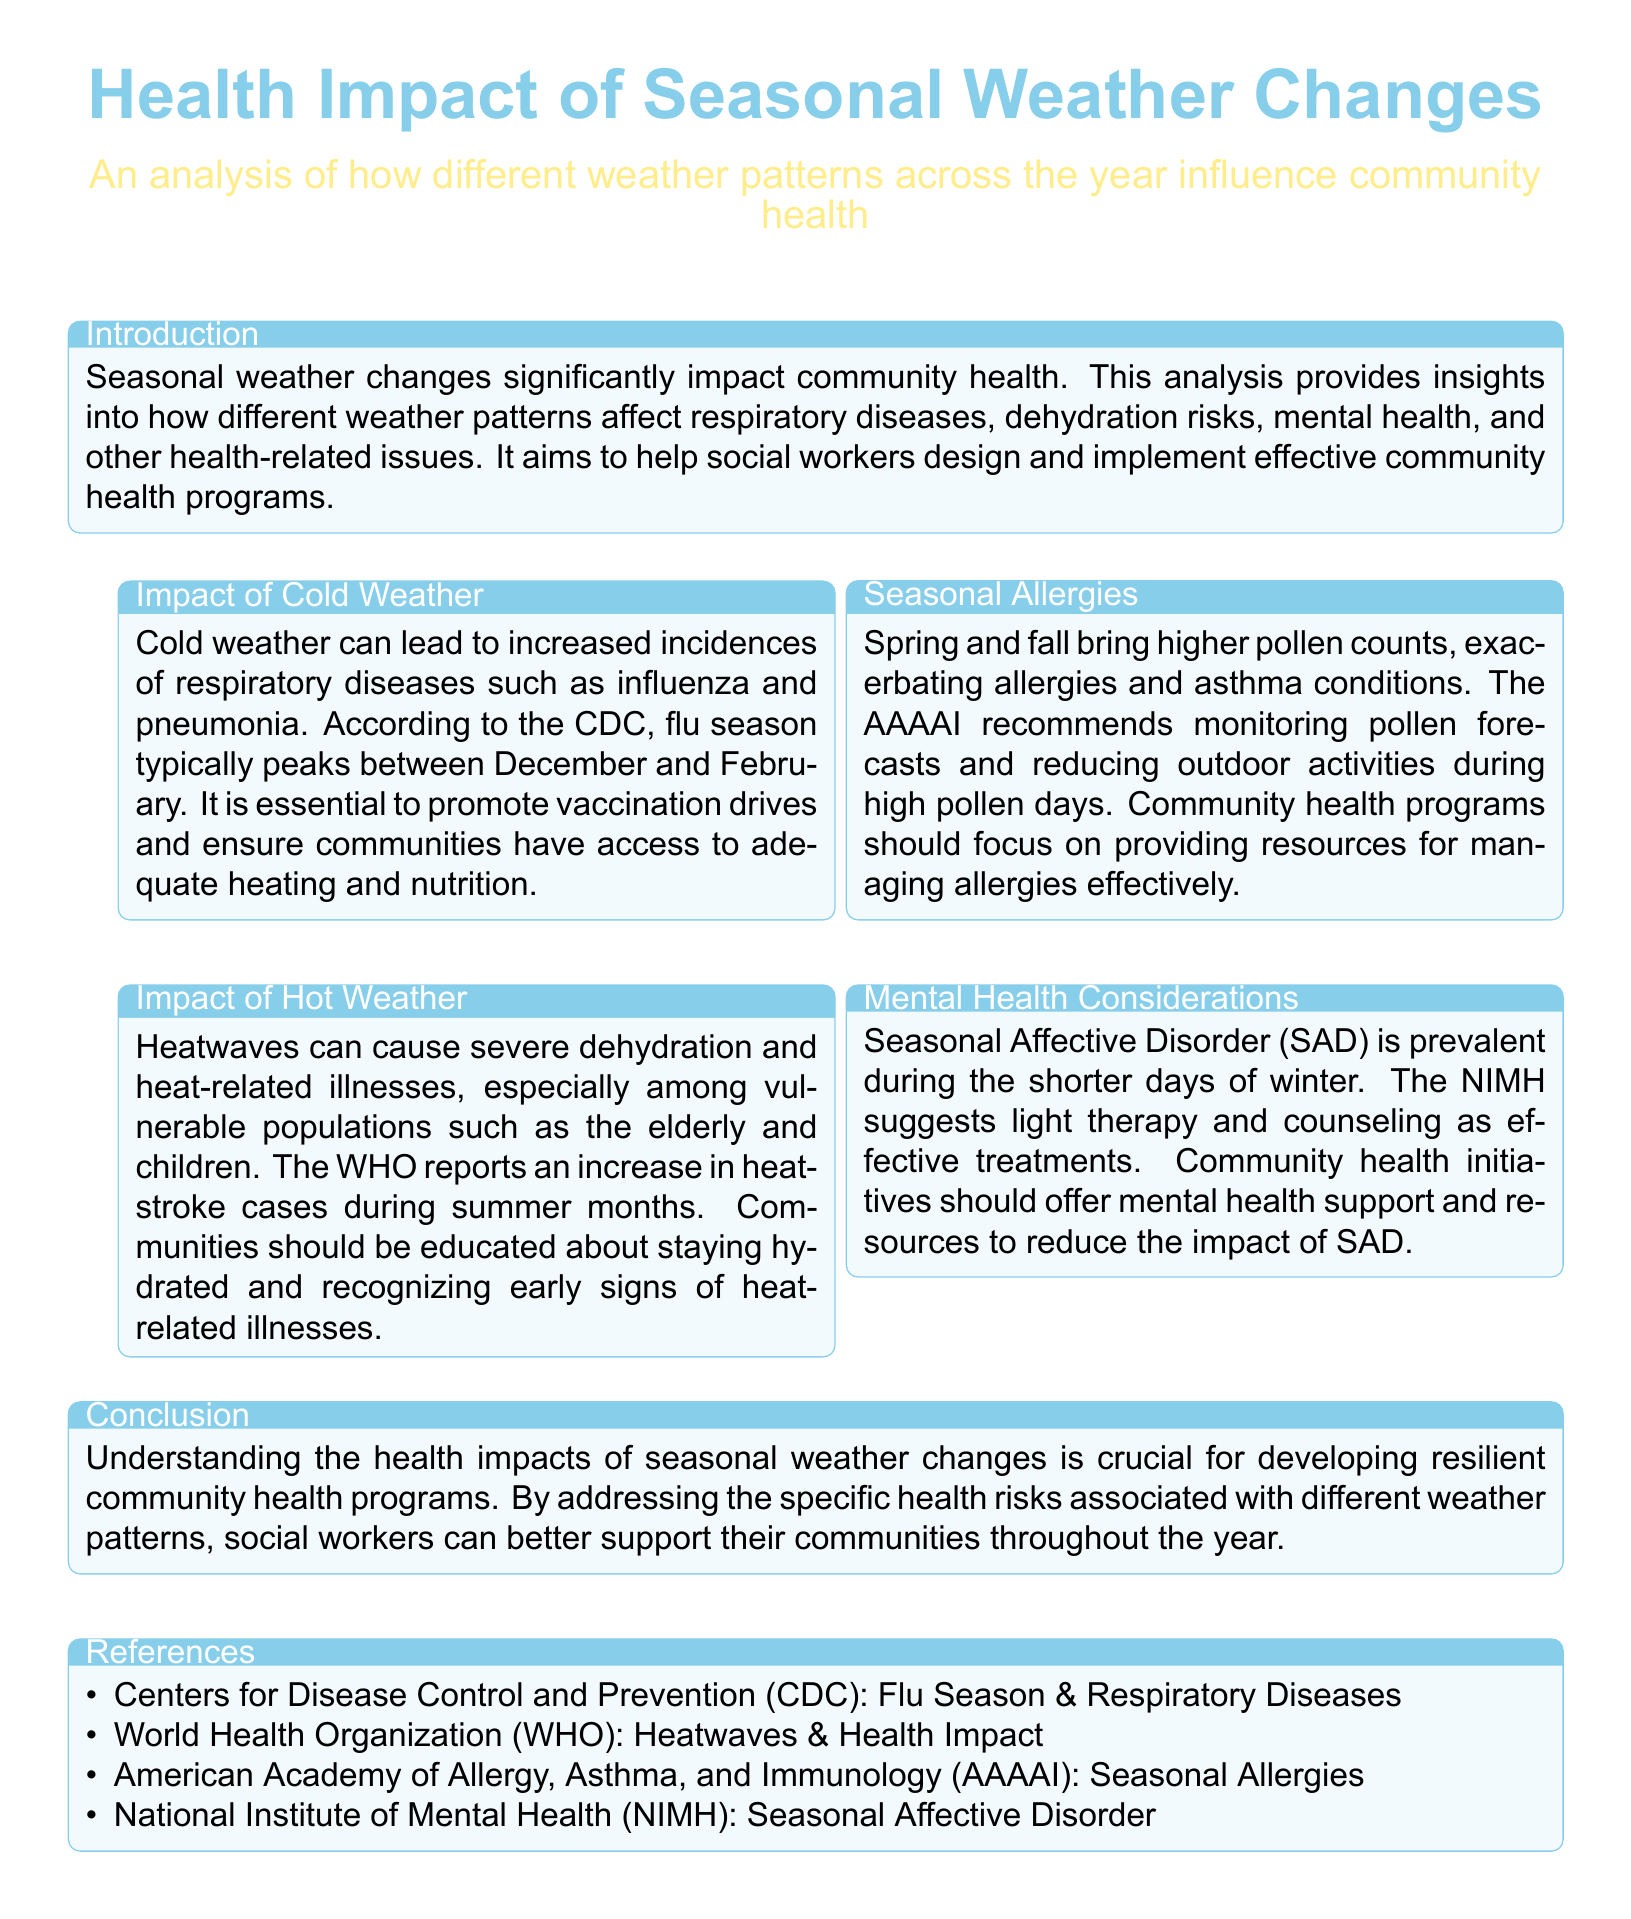What is the peak flu season? The document states that flu season typically peaks between December and February.
Answer: December and February What are the health impacts of cold weather? The cold weather can lead to increased incidences of respiratory diseases such as influenza and pneumonia.
Answer: Respiratory diseases What should communities promote during cold months? The document emphasizes the importance of promoting vaccination drives and ensuring communities have access to adequate heating and nutrition.
Answer: Vaccination drives What illness does heatwave primarily cause? According to the document, heatwaves can cause severe dehydration and heat-related illnesses.
Answer: Dehydration Which population is particularly vulnerable during heatwaves? The document mentions that vulnerable populations include the elderly and children.
Answer: Elderly and children What condition is prevalent during the shorter days of winter? The document states that Seasonal Affective Disorder (SAD) is prevalent during this time.
Answer: Seasonal Affective Disorder Which organization recommends monitoring pollen forecasts? The American Academy of Allergy, Asthma, and Immunology (AAAAI) recommends this.
Answer: AAAAI What type of support should community health initiatives offer for mental health? Community health initiatives should offer mental health support and resources.
Answer: Mental health support 